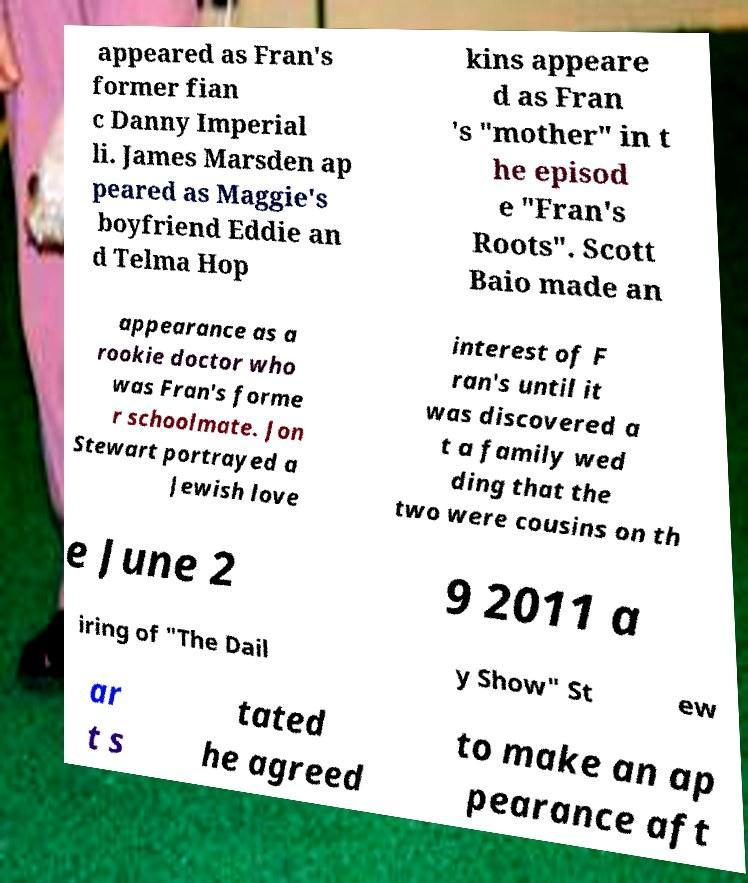I need the written content from this picture converted into text. Can you do that? appeared as Fran's former fian c Danny Imperial li. James Marsden ap peared as Maggie's boyfriend Eddie an d Telma Hop kins appeare d as Fran 's "mother" in t he episod e "Fran's Roots". Scott Baio made an appearance as a rookie doctor who was Fran's forme r schoolmate. Jon Stewart portrayed a Jewish love interest of F ran's until it was discovered a t a family wed ding that the two were cousins on th e June 2 9 2011 a iring of "The Dail y Show" St ew ar t s tated he agreed to make an ap pearance aft 